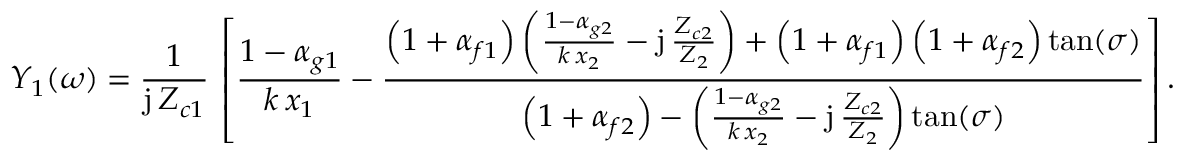Convert formula to latex. <formula><loc_0><loc_0><loc_500><loc_500>Y _ { 1 } ( \omega ) = \frac { 1 } { j \, Z _ { c 1 } } \, \left [ \frac { 1 - { \alpha } _ { g 1 } } { k \, x _ { 1 } } - \frac { \left ( 1 + { \alpha } _ { f 1 } \right ) \left ( \frac { 1 - { \alpha } _ { g 2 } } { k \, x _ { 2 } } - j \, \frac { Z _ { c 2 } } { Z _ { 2 } } \right ) + \left ( 1 + { \alpha } _ { f 1 } \right ) \left ( 1 + { \alpha } _ { f 2 } \right ) \tan ( \sigma ) } { \left ( 1 + { \alpha } _ { f 2 } \right ) - \left ( \frac { 1 - { \alpha } _ { g 2 } } { k \, x _ { 2 } } - j \, \frac { Z _ { c 2 } } { Z _ { 2 } } \right ) \tan ( \sigma ) } \right ] .</formula> 